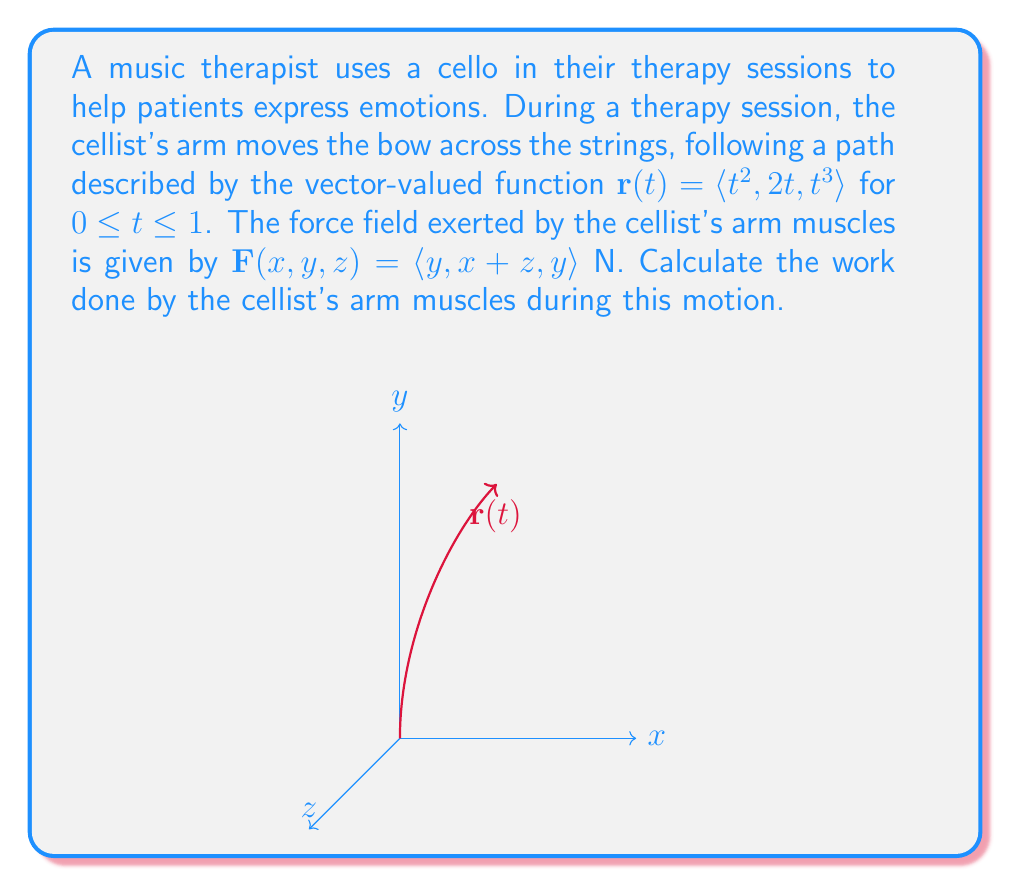Solve this math problem. To compute the work done by the cellist's arm muscles, we need to evaluate the line integral of the force field along the given path. The work is given by:

$$W = \int_C \mathbf{F} \cdot d\mathbf{r}$$

where $C$ is the path described by $\mathbf{r}(t)$.

Step 1: Express $d\mathbf{r}$ in terms of $t$.
$$\frac{d\mathbf{r}}{dt} = \langle 2t, 2, 3t^2 \rangle$$
$$d\mathbf{r} = \langle 2t, 2, 3t^2 \rangle dt$$

Step 2: Evaluate $\mathbf{F}(\mathbf{r}(t))$.
$$\mathbf{F}(\mathbf{r}(t)) = \langle 2t, t^2+t^3, 2t \rangle$$

Step 3: Compute the dot product $\mathbf{F} \cdot d\mathbf{r}$.
$$\mathbf{F} \cdot d\mathbf{r} = (2t)(2t)dt + (t^2+t^3)(2)dt + (2t)(3t^2)dt$$
$$\mathbf{F} \cdot d\mathbf{r} = (4t^2 + 2t^2 + 2t^3 + 6t^3)dt$$
$$\mathbf{F} \cdot d\mathbf{r} = (6t^2 + 8t^3)dt$$

Step 4: Integrate from $t=0$ to $t=1$.
$$W = \int_0^1 (6t^2 + 8t^3)dt$$
$$W = \left[2t^3 + 2t^4\right]_0^1$$
$$W = (2 + 2) - (0 + 0) = 4$$

Therefore, the work done by the cellist's arm muscles during this motion is 4 joules.
Answer: 4 J 